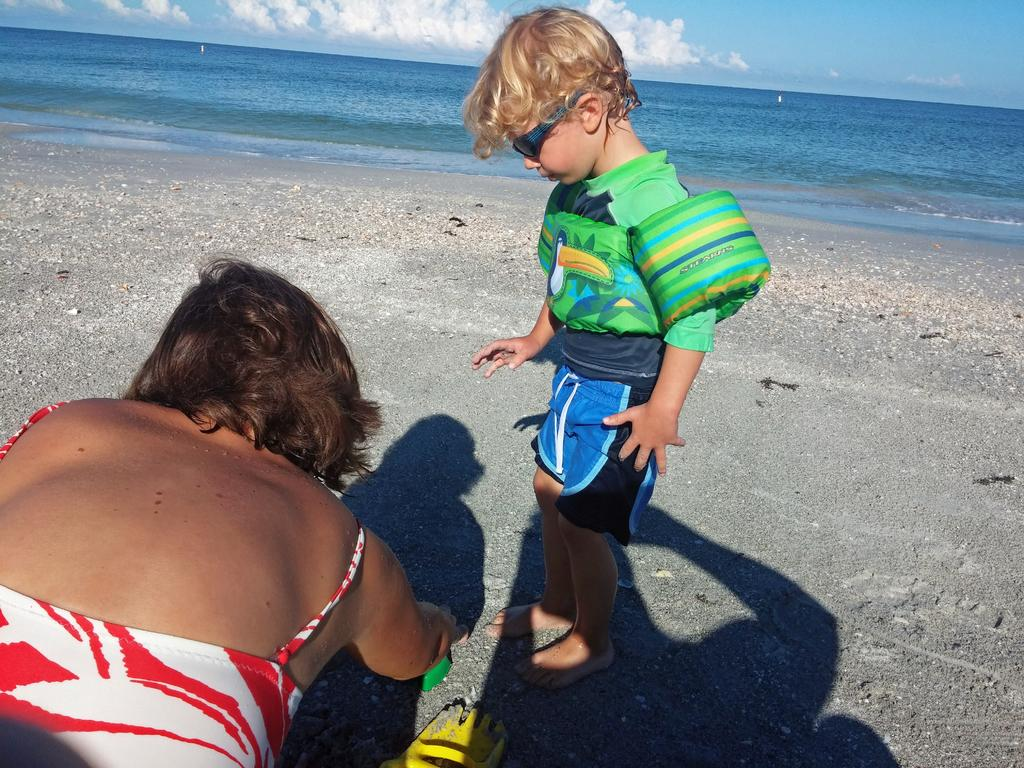Where was the image taken? The image was taken at a beach. What can be seen at the top of the image? Water and sky are visible at the top of the image. How many people are in the image? There are two people in the image. Can you describe the people in the image? One of the people is a woman, and the other person is a kid. Is there a bridge visible in the image? No, there is no bridge present in the image. What type of yard can be seen in the background of the image? There is no yard visible in the image, as it was taken at a beach. 